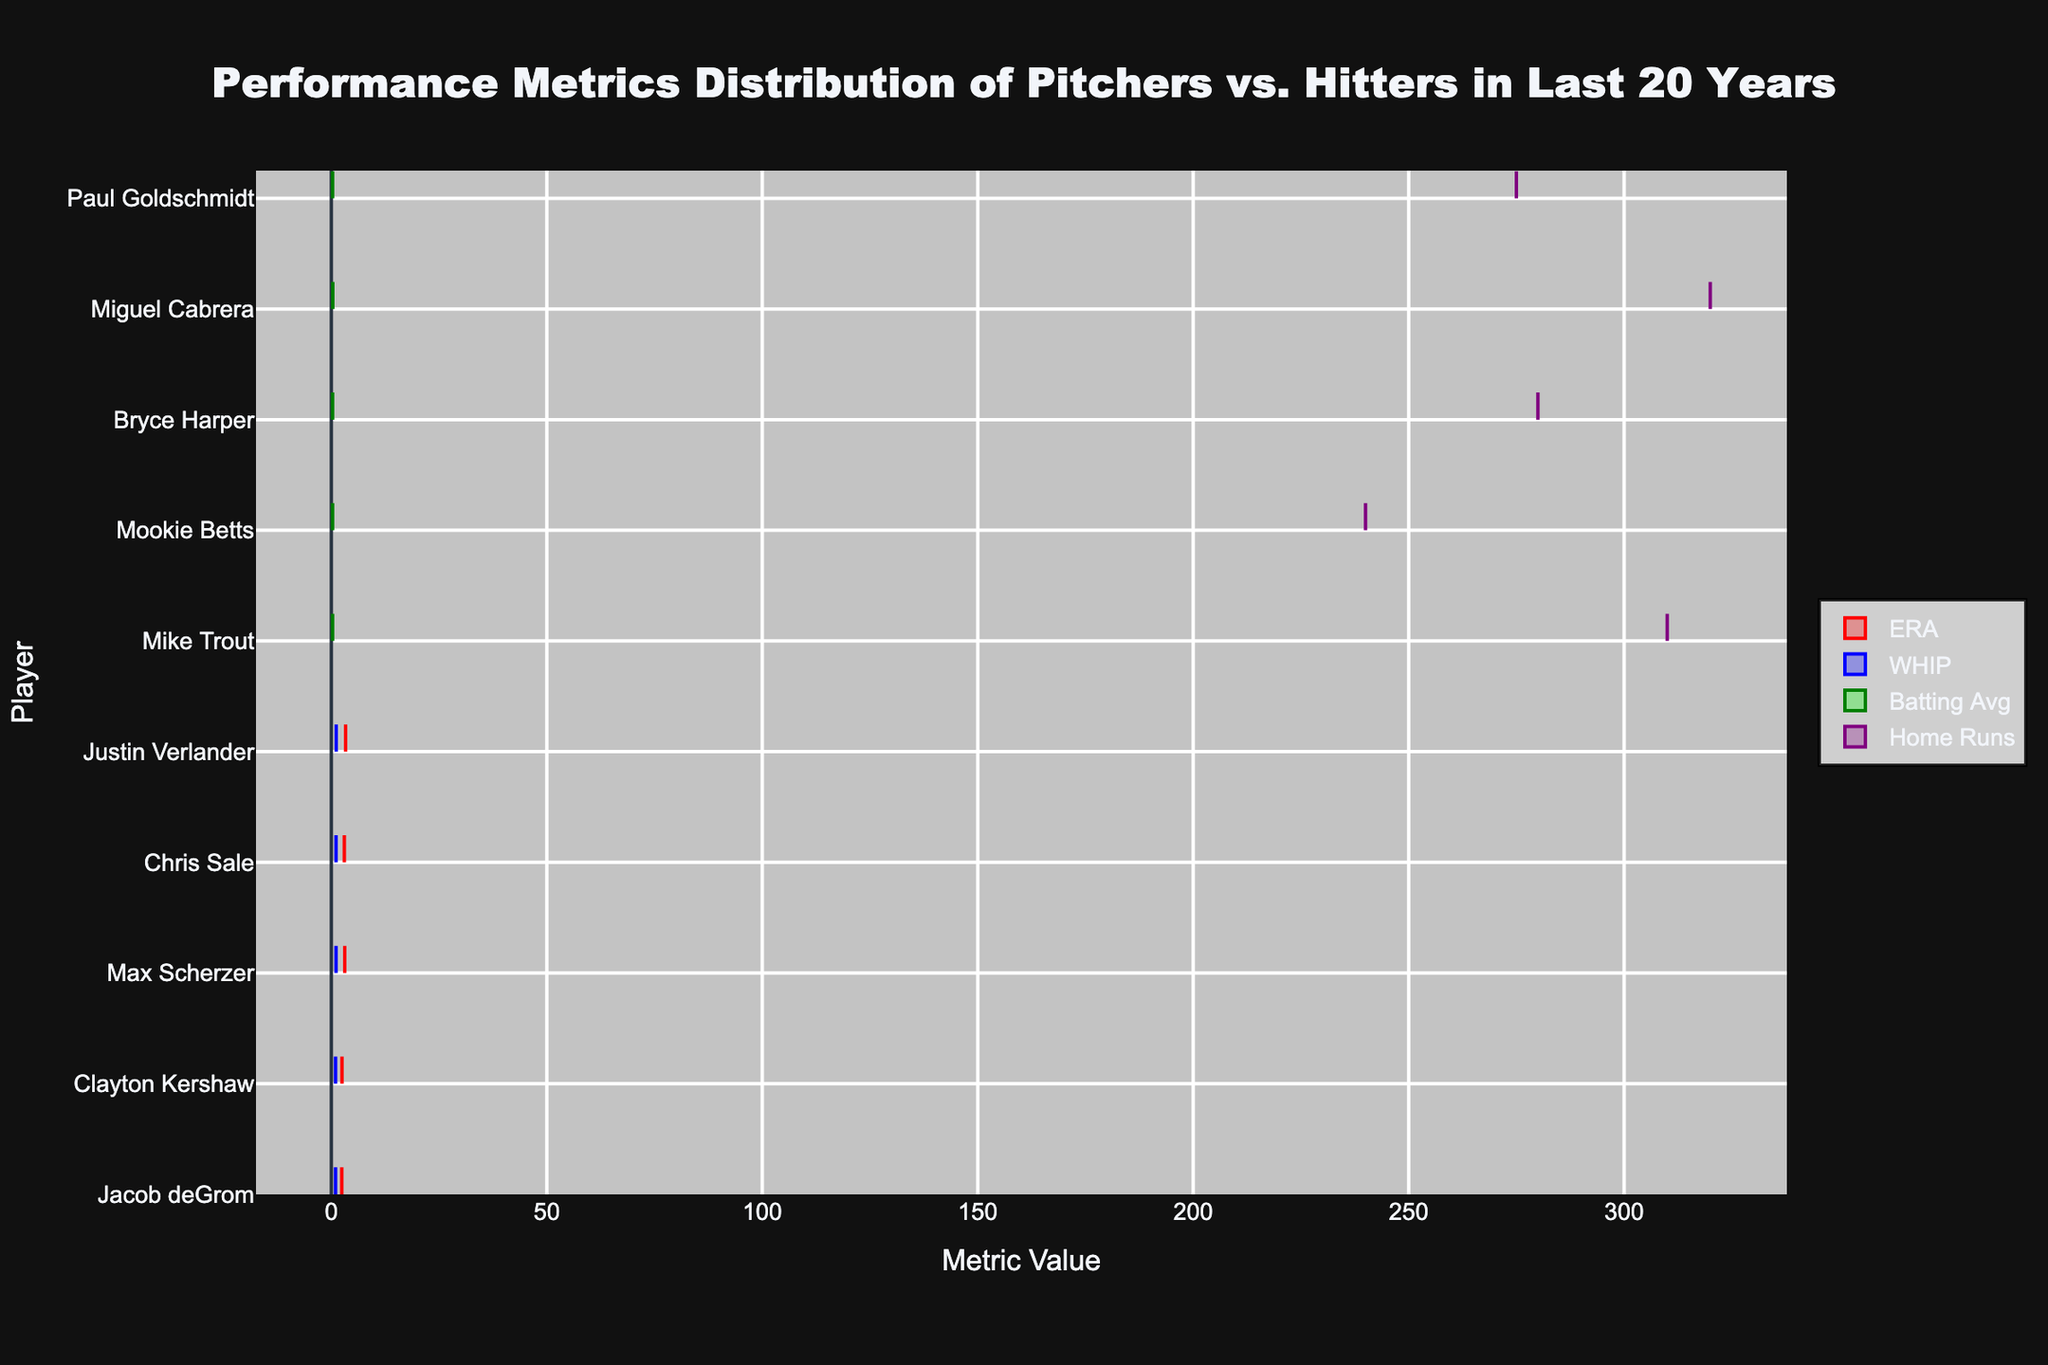what's the title of the chart? The title is displayed at the top of the chart in a larger and bold font, making it easily noticeable
Answer: Performance Metrics Distribution of Pitchers vs. Hitters in Last 20 Years how many players are shown in the chart? Count the distinct player names listed on the y-axis
Answer: 10 what color represents WHIP in the chart? Look for the color used in the legend next to the 'WHIP' label
Answer: Blue which role has the metric 'Home Runs' displayed in the chart? Identify whether 'Home Runs' is associated with pitchers or hitters by referencing the legend and corresponding side
Answer: Hitters who has the highest batting average among hitters? Find the player with the farthest 'green' violin plot extending to the right on the x-axis under 'Batting Avg'
Answer: Miguel Cabrera which pitcher has the lowest ERA? Look for the farthest 'red' violin plot to the left on the x-axis under 'ERA'
Answer: Jacob deGrom who has lower WHIP, Jacob deGrom or Justin Verlander? Compare the extent of the 'blue' violin plots for Jacob deGrom and Justin Verlander on the x-axis
Answer: Jacob deGrom what is the range of home runs hit by Bryce Harper? Determine the extent of the 'purple' violin plot to find its minimum and maximum values on the x-axis under 'Home Runs' for Bryce Harper
Answer: Range is 280 what's the average WHIP of all pitchers? Sum the WHIP values of all pitchers and divide by the number of pitchers: (0.99 + 1.00 + 1.08 + 1.06 + 1.13) / 5
Answer: 1.052 do hitters have any representations for ERA or WHIP? Check if there are 'red' or 'blue' violin plots associated with any of the hitters
Answer: No compare the ERA between Jacob deGrom and Max Scherzer Note the shorter 'red' violin plot on the x-axis between Jacob deGrom and Max Scherzer; deGrom's plot is on the left (indicating lower values) while Scherzer's is towards the right
Answer: Jacob deGrom has a lower ERA than Max Scherzer 